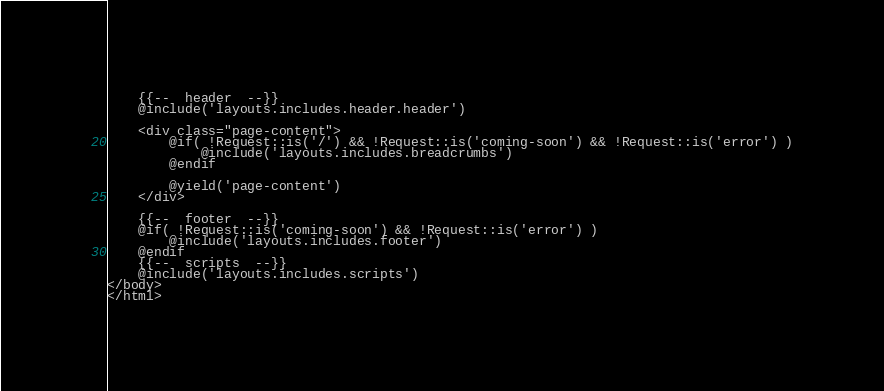Convert code to text. <code><loc_0><loc_0><loc_500><loc_500><_PHP_>
    {{--  header  --}}
    @include('layouts.includes.header.header')

    <div class="page-content">
        @if( !Request::is('/') && !Request::is('coming-soon') && !Request::is('error') )
            @include('layouts.includes.breadcrumbs')
        @endif

        @yield('page-content')
    </div>

    {{--  footer  --}}
    @if( !Request::is('coming-soon') && !Request::is('error') )
        @include('layouts.includes.footer')
    @endif
    {{--  scripts  --}}
    @include('layouts.includes.scripts')
</body>
</html>
</code> 